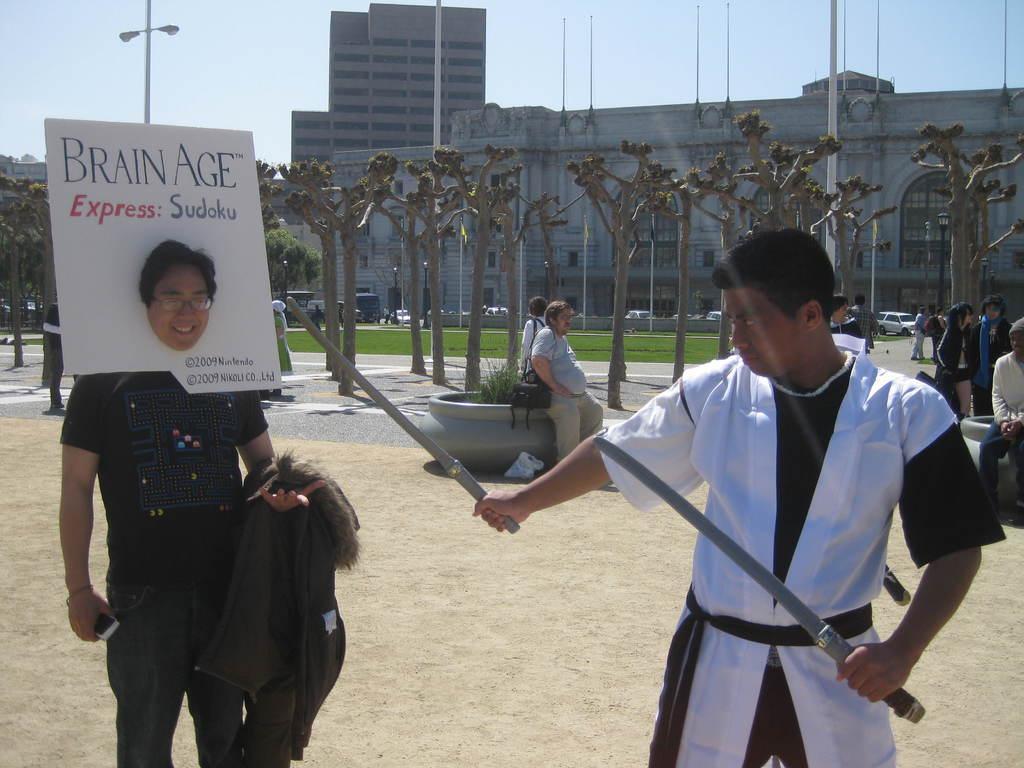Please provide a concise description of this image. In this image, we can see a person wearing a coat and holding swords and there is an other person holding a coat and a mobile and wearing a board. In the background, there are trees and we can see buildings, lights and poles and there are some other people and we can see a flower pot. At the bottom, there is a road. 